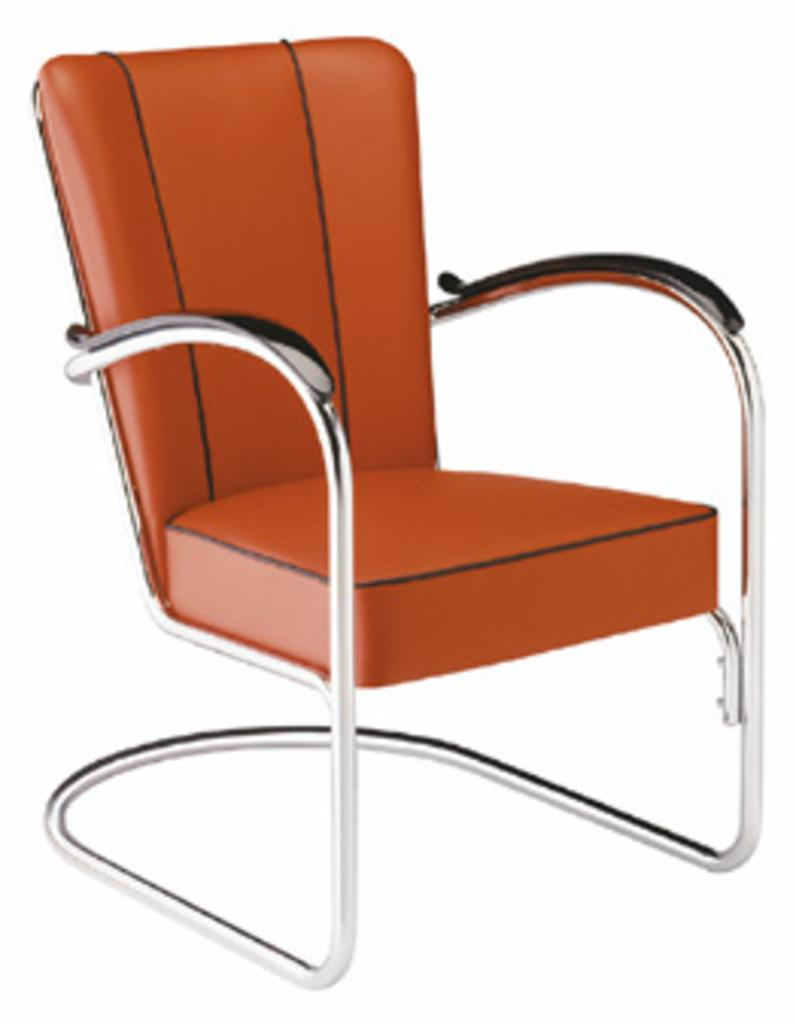What type of furniture is in the image? There is a chair in the image. What is the color of the chair's seat? The chair has a brown seat. What material is used for the handle of the chair? The chair has a wooden handle. What type of material is used for the legs of the chair? The chair has steel legs. What type of coat is hanging on the chair in the image? There is no coat present in the image; only the chair is visible. 